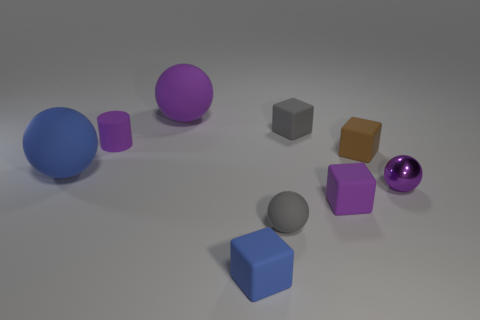Subtract all small gray matte balls. How many balls are left? 3 Add 1 tiny purple metallic things. How many objects exist? 10 Subtract all purple balls. How many balls are left? 2 Subtract all gray cylinders. Subtract all purple spheres. How many cylinders are left? 1 Subtract all gray spheres. How many purple blocks are left? 1 Subtract all tiny gray things. Subtract all large objects. How many objects are left? 5 Add 2 small brown rubber cubes. How many small brown rubber cubes are left? 3 Add 2 small blocks. How many small blocks exist? 6 Subtract 1 gray cubes. How many objects are left? 8 Subtract all balls. How many objects are left? 5 